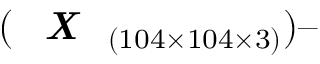<formula> <loc_0><loc_0><loc_500><loc_500>( X _ { ( 1 0 4 \times 1 0 4 \times 3 ) } )</formula> 